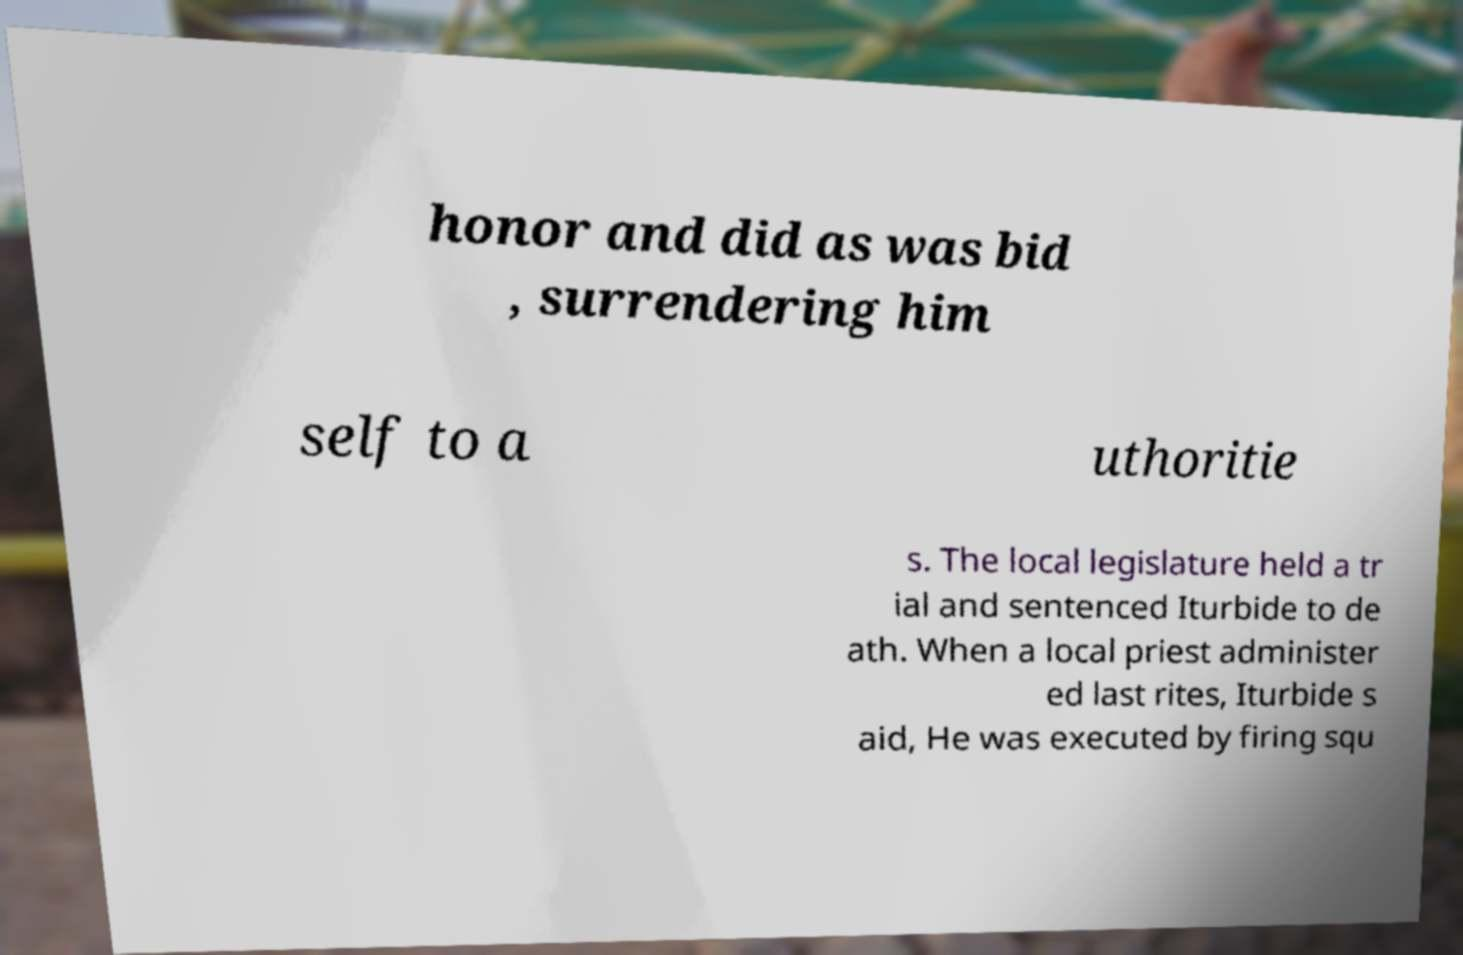Please identify and transcribe the text found in this image. honor and did as was bid , surrendering him self to a uthoritie s. The local legislature held a tr ial and sentenced Iturbide to de ath. When a local priest administer ed last rites, Iturbide s aid, He was executed by firing squ 